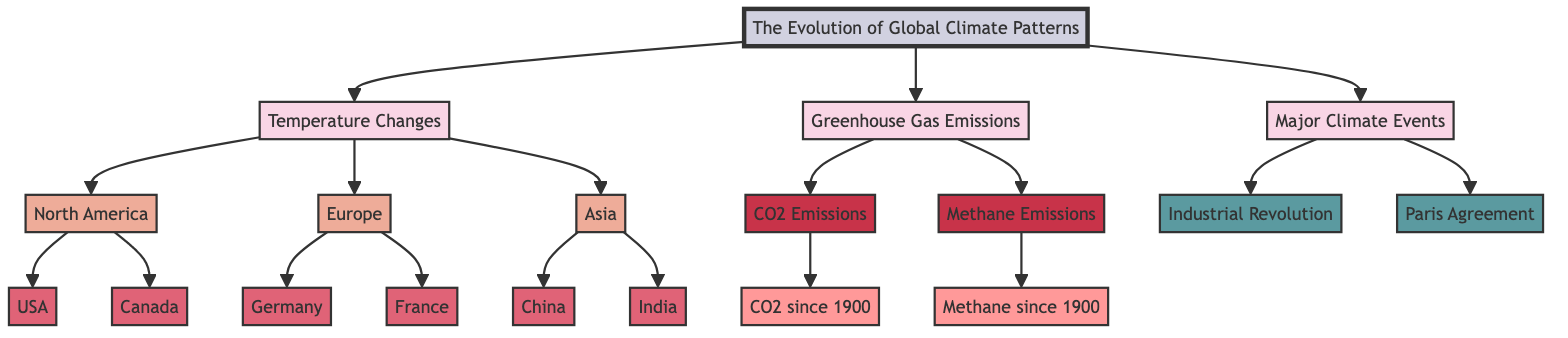What are the three main categories presented in the diagram? The three main categories are identified as Temperature Changes, Greenhouse Gas Emissions, and Major Climate Events, which are clearly labeled in the diagram.
Answer: Temperature Changes, Greenhouse Gas Emissions, Major Climate Events Which countries are included under North America? The diagram specifies North America includes the USA and Canada as the countries linked under that region.
Answer: USA, Canada How many subcategories of greenhouse gas emissions are identified in the diagram? The diagram indicates there are two subcategories of greenhouse gas emissions, specifically CO2 Emissions and Methane Emissions, linked from the Greenhouse Gas Emissions category.
Answer: 2 Which major climate event follows the Industrial Revolution in the diagram? The diagram shows that the Paris Agreement is the second major climate event, following the Industrial Revolution, indicating the chronological relationship between these two events.
Answer: Paris Agreement What has been the trend for CO2 emissions since 1900 as shown in the diagram? The diagram includes a mention of CO2 since 1900, implying increased levels of CO2 emissions over the century, but specific values or trends would need additional quantitative data for a precise statement.
Answer: Increased How many geographical regions are represented in the diagram? The diagram exhibits three geographical regions: North America, Europe, and Asia, which are each distinct sections linked from the Temperature Changes category.
Answer: 3 What key climate event is associated with the year 1900? The Industrial Revolution is associated with the year 1900 as the diagram links this event within the context of major climate changes.
Answer: Industrial Revolution Which country under Asia is included in the diagram? The countries identified under Asia include China and India, as presented in the diagram's regional classification.
Answer: China, India What two types of emissions are tracked since 1900 according to the diagram? The diagram illustrates that both CO2 emissions and Methane emissions are tracked since 1900, making them the main types of emissions monitored over this period.
Answer: CO2, Methane 